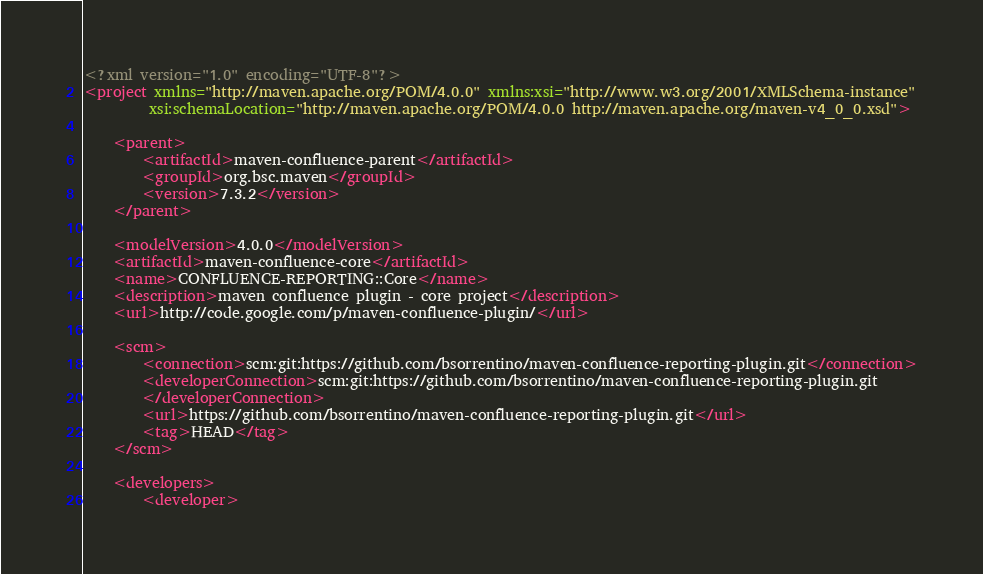<code> <loc_0><loc_0><loc_500><loc_500><_XML_><?xml version="1.0" encoding="UTF-8"?>
<project xmlns="http://maven.apache.org/POM/4.0.0" xmlns:xsi="http://www.w3.org/2001/XMLSchema-instance"
         xsi:schemaLocation="http://maven.apache.org/POM/4.0.0 http://maven.apache.org/maven-v4_0_0.xsd">

    <parent>
        <artifactId>maven-confluence-parent</artifactId>
        <groupId>org.bsc.maven</groupId>
        <version>7.3.2</version>
    </parent>

    <modelVersion>4.0.0</modelVersion>
    <artifactId>maven-confluence-core</artifactId>
    <name>CONFLUENCE-REPORTING::Core</name>
    <description>maven confluence plugin - core project</description>
    <url>http://code.google.com/p/maven-confluence-plugin/</url>

    <scm>
        <connection>scm:git:https://github.com/bsorrentino/maven-confluence-reporting-plugin.git</connection>
        <developerConnection>scm:git:https://github.com/bsorrentino/maven-confluence-reporting-plugin.git
        </developerConnection>
        <url>https://github.com/bsorrentino/maven-confluence-reporting-plugin.git</url>
        <tag>HEAD</tag>
    </scm>

    <developers>
        <developer></code> 